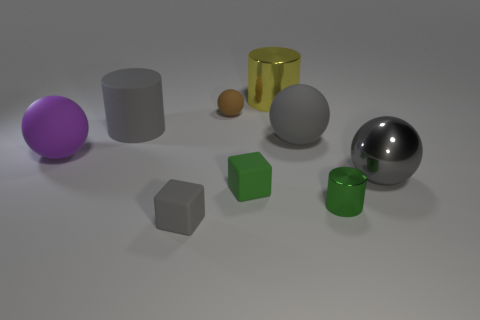Subtract all balls. How many objects are left? 5 Subtract 0 yellow balls. How many objects are left? 9 Subtract all green spheres. Subtract all yellow things. How many objects are left? 8 Add 3 gray spheres. How many gray spheres are left? 5 Add 6 small green cylinders. How many small green cylinders exist? 7 